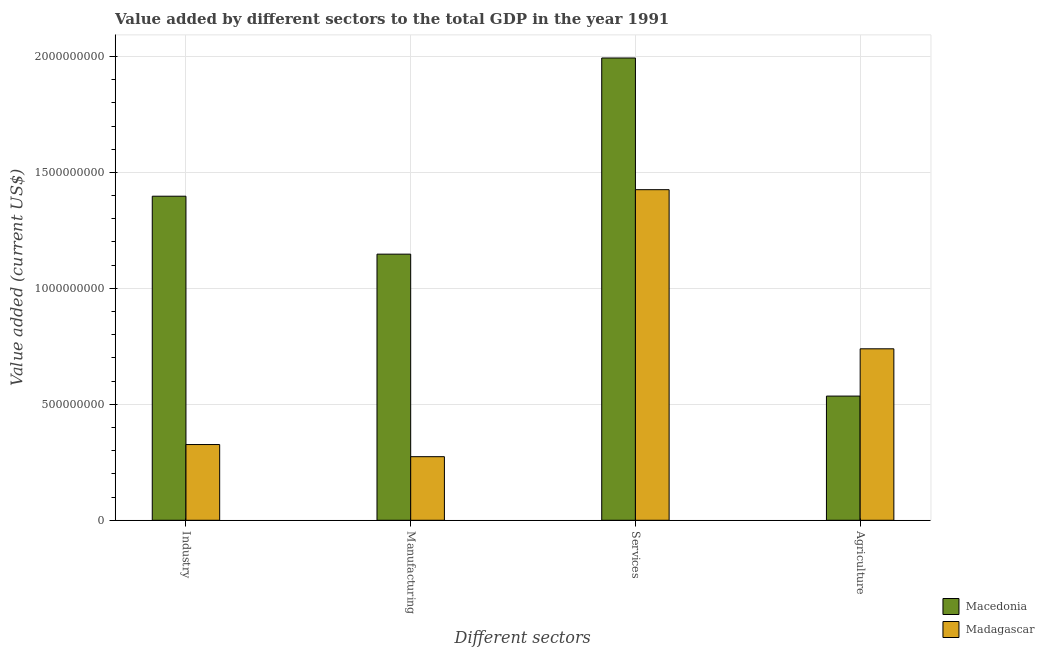How many different coloured bars are there?
Ensure brevity in your answer.  2. What is the label of the 1st group of bars from the left?
Your answer should be very brief. Industry. What is the value added by services sector in Macedonia?
Offer a very short reply. 1.99e+09. Across all countries, what is the maximum value added by manufacturing sector?
Ensure brevity in your answer.  1.15e+09. Across all countries, what is the minimum value added by agricultural sector?
Offer a terse response. 5.36e+08. In which country was the value added by agricultural sector maximum?
Your answer should be compact. Madagascar. In which country was the value added by services sector minimum?
Make the answer very short. Madagascar. What is the total value added by services sector in the graph?
Ensure brevity in your answer.  3.42e+09. What is the difference between the value added by services sector in Madagascar and that in Macedonia?
Your answer should be very brief. -5.68e+08. What is the difference between the value added by services sector in Madagascar and the value added by industrial sector in Macedonia?
Your answer should be very brief. 2.82e+07. What is the average value added by agricultural sector per country?
Provide a short and direct response. 6.37e+08. What is the difference between the value added by services sector and value added by industrial sector in Macedonia?
Make the answer very short. 5.96e+08. What is the ratio of the value added by agricultural sector in Madagascar to that in Macedonia?
Ensure brevity in your answer.  1.38. Is the difference between the value added by industrial sector in Macedonia and Madagascar greater than the difference between the value added by agricultural sector in Macedonia and Madagascar?
Give a very brief answer. Yes. What is the difference between the highest and the second highest value added by services sector?
Make the answer very short. 5.68e+08. What is the difference between the highest and the lowest value added by manufacturing sector?
Provide a succinct answer. 8.73e+08. In how many countries, is the value added by services sector greater than the average value added by services sector taken over all countries?
Provide a succinct answer. 1. What does the 2nd bar from the left in Services represents?
Ensure brevity in your answer.  Madagascar. What does the 2nd bar from the right in Agriculture represents?
Make the answer very short. Macedonia. Is it the case that in every country, the sum of the value added by industrial sector and value added by manufacturing sector is greater than the value added by services sector?
Your response must be concise. No. How many bars are there?
Your response must be concise. 8. Are all the bars in the graph horizontal?
Provide a succinct answer. No. How many countries are there in the graph?
Ensure brevity in your answer.  2. What is the title of the graph?
Your response must be concise. Value added by different sectors to the total GDP in the year 1991. What is the label or title of the X-axis?
Provide a short and direct response. Different sectors. What is the label or title of the Y-axis?
Your response must be concise. Value added (current US$). What is the Value added (current US$) of Macedonia in Industry?
Your answer should be compact. 1.40e+09. What is the Value added (current US$) in Madagascar in Industry?
Your response must be concise. 3.27e+08. What is the Value added (current US$) in Macedonia in Manufacturing?
Offer a very short reply. 1.15e+09. What is the Value added (current US$) of Madagascar in Manufacturing?
Your answer should be very brief. 2.74e+08. What is the Value added (current US$) of Macedonia in Services?
Your response must be concise. 1.99e+09. What is the Value added (current US$) in Madagascar in Services?
Offer a very short reply. 1.43e+09. What is the Value added (current US$) of Macedonia in Agriculture?
Your answer should be compact. 5.36e+08. What is the Value added (current US$) in Madagascar in Agriculture?
Provide a short and direct response. 7.39e+08. Across all Different sectors, what is the maximum Value added (current US$) in Macedonia?
Keep it short and to the point. 1.99e+09. Across all Different sectors, what is the maximum Value added (current US$) in Madagascar?
Give a very brief answer. 1.43e+09. Across all Different sectors, what is the minimum Value added (current US$) of Macedonia?
Provide a succinct answer. 5.36e+08. Across all Different sectors, what is the minimum Value added (current US$) of Madagascar?
Your response must be concise. 2.74e+08. What is the total Value added (current US$) of Macedonia in the graph?
Provide a short and direct response. 5.07e+09. What is the total Value added (current US$) of Madagascar in the graph?
Ensure brevity in your answer.  2.77e+09. What is the difference between the Value added (current US$) in Macedonia in Industry and that in Manufacturing?
Make the answer very short. 2.50e+08. What is the difference between the Value added (current US$) in Madagascar in Industry and that in Manufacturing?
Provide a succinct answer. 5.23e+07. What is the difference between the Value added (current US$) of Macedonia in Industry and that in Services?
Your answer should be compact. -5.96e+08. What is the difference between the Value added (current US$) in Madagascar in Industry and that in Services?
Your answer should be very brief. -1.10e+09. What is the difference between the Value added (current US$) of Macedonia in Industry and that in Agriculture?
Offer a very short reply. 8.62e+08. What is the difference between the Value added (current US$) of Madagascar in Industry and that in Agriculture?
Your answer should be compact. -4.13e+08. What is the difference between the Value added (current US$) of Macedonia in Manufacturing and that in Services?
Offer a very short reply. -8.46e+08. What is the difference between the Value added (current US$) in Madagascar in Manufacturing and that in Services?
Give a very brief answer. -1.15e+09. What is the difference between the Value added (current US$) in Macedonia in Manufacturing and that in Agriculture?
Provide a succinct answer. 6.12e+08. What is the difference between the Value added (current US$) in Madagascar in Manufacturing and that in Agriculture?
Offer a very short reply. -4.65e+08. What is the difference between the Value added (current US$) of Macedonia in Services and that in Agriculture?
Offer a very short reply. 1.46e+09. What is the difference between the Value added (current US$) of Madagascar in Services and that in Agriculture?
Make the answer very short. 6.86e+08. What is the difference between the Value added (current US$) of Macedonia in Industry and the Value added (current US$) of Madagascar in Manufacturing?
Provide a succinct answer. 1.12e+09. What is the difference between the Value added (current US$) in Macedonia in Industry and the Value added (current US$) in Madagascar in Services?
Provide a succinct answer. -2.82e+07. What is the difference between the Value added (current US$) of Macedonia in Industry and the Value added (current US$) of Madagascar in Agriculture?
Keep it short and to the point. 6.58e+08. What is the difference between the Value added (current US$) in Macedonia in Manufacturing and the Value added (current US$) in Madagascar in Services?
Offer a very short reply. -2.78e+08. What is the difference between the Value added (current US$) of Macedonia in Manufacturing and the Value added (current US$) of Madagascar in Agriculture?
Give a very brief answer. 4.08e+08. What is the difference between the Value added (current US$) in Macedonia in Services and the Value added (current US$) in Madagascar in Agriculture?
Provide a short and direct response. 1.25e+09. What is the average Value added (current US$) of Macedonia per Different sectors?
Provide a short and direct response. 1.27e+09. What is the average Value added (current US$) of Madagascar per Different sectors?
Your response must be concise. 6.91e+08. What is the difference between the Value added (current US$) of Macedonia and Value added (current US$) of Madagascar in Industry?
Your answer should be compact. 1.07e+09. What is the difference between the Value added (current US$) in Macedonia and Value added (current US$) in Madagascar in Manufacturing?
Provide a short and direct response. 8.73e+08. What is the difference between the Value added (current US$) of Macedonia and Value added (current US$) of Madagascar in Services?
Offer a terse response. 5.68e+08. What is the difference between the Value added (current US$) of Macedonia and Value added (current US$) of Madagascar in Agriculture?
Give a very brief answer. -2.04e+08. What is the ratio of the Value added (current US$) in Macedonia in Industry to that in Manufacturing?
Provide a succinct answer. 1.22. What is the ratio of the Value added (current US$) of Madagascar in Industry to that in Manufacturing?
Provide a short and direct response. 1.19. What is the ratio of the Value added (current US$) of Macedonia in Industry to that in Services?
Your answer should be compact. 0.7. What is the ratio of the Value added (current US$) in Madagascar in Industry to that in Services?
Provide a succinct answer. 0.23. What is the ratio of the Value added (current US$) in Macedonia in Industry to that in Agriculture?
Give a very brief answer. 2.61. What is the ratio of the Value added (current US$) of Madagascar in Industry to that in Agriculture?
Your response must be concise. 0.44. What is the ratio of the Value added (current US$) of Macedonia in Manufacturing to that in Services?
Your response must be concise. 0.58. What is the ratio of the Value added (current US$) in Madagascar in Manufacturing to that in Services?
Give a very brief answer. 0.19. What is the ratio of the Value added (current US$) of Macedonia in Manufacturing to that in Agriculture?
Provide a succinct answer. 2.14. What is the ratio of the Value added (current US$) of Madagascar in Manufacturing to that in Agriculture?
Provide a short and direct response. 0.37. What is the ratio of the Value added (current US$) in Macedonia in Services to that in Agriculture?
Your answer should be very brief. 3.72. What is the ratio of the Value added (current US$) in Madagascar in Services to that in Agriculture?
Provide a short and direct response. 1.93. What is the difference between the highest and the second highest Value added (current US$) of Macedonia?
Provide a succinct answer. 5.96e+08. What is the difference between the highest and the second highest Value added (current US$) of Madagascar?
Offer a very short reply. 6.86e+08. What is the difference between the highest and the lowest Value added (current US$) of Macedonia?
Your answer should be very brief. 1.46e+09. What is the difference between the highest and the lowest Value added (current US$) in Madagascar?
Your response must be concise. 1.15e+09. 